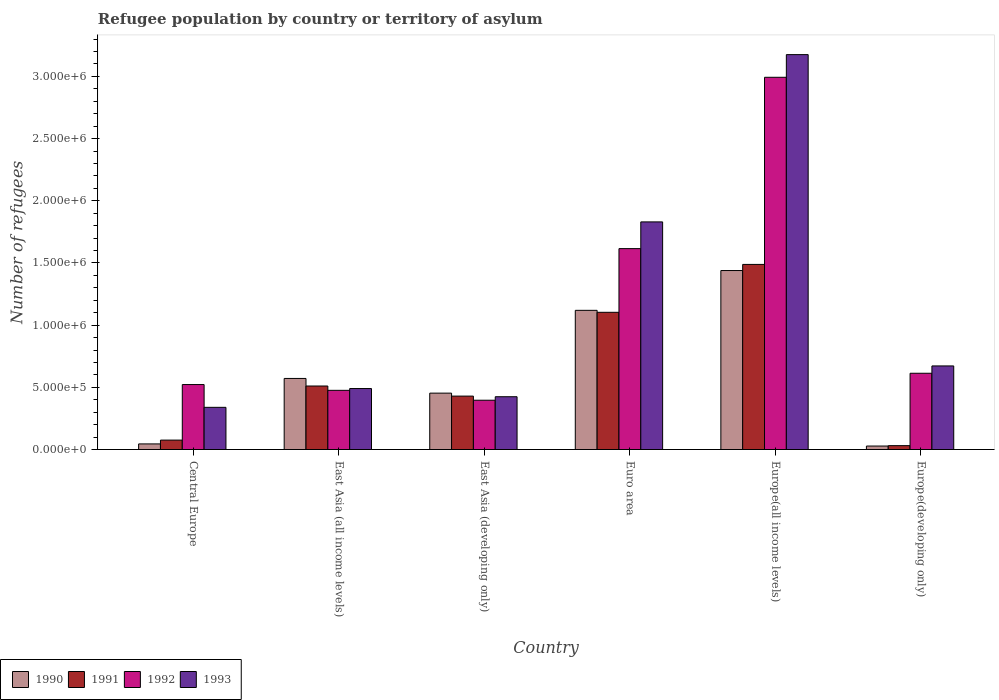Are the number of bars on each tick of the X-axis equal?
Your answer should be compact. Yes. What is the label of the 1st group of bars from the left?
Ensure brevity in your answer.  Central Europe. In how many cases, is the number of bars for a given country not equal to the number of legend labels?
Offer a very short reply. 0. What is the number of refugees in 1991 in Central Europe?
Your response must be concise. 7.57e+04. Across all countries, what is the maximum number of refugees in 1992?
Make the answer very short. 2.99e+06. Across all countries, what is the minimum number of refugees in 1992?
Provide a short and direct response. 3.96e+05. In which country was the number of refugees in 1990 maximum?
Keep it short and to the point. Europe(all income levels). In which country was the number of refugees in 1992 minimum?
Ensure brevity in your answer.  East Asia (developing only). What is the total number of refugees in 1993 in the graph?
Your response must be concise. 6.93e+06. What is the difference between the number of refugees in 1991 in Central Europe and that in East Asia (all income levels)?
Keep it short and to the point. -4.35e+05. What is the difference between the number of refugees in 1991 in Central Europe and the number of refugees in 1992 in East Asia (all income levels)?
Provide a succinct answer. -4.00e+05. What is the average number of refugees in 1992 per country?
Your answer should be compact. 1.10e+06. What is the difference between the number of refugees of/in 1992 and number of refugees of/in 1991 in Euro area?
Your response must be concise. 5.12e+05. What is the ratio of the number of refugees in 1992 in Central Europe to that in Euro area?
Provide a succinct answer. 0.32. What is the difference between the highest and the second highest number of refugees in 1990?
Keep it short and to the point. 5.48e+05. What is the difference between the highest and the lowest number of refugees in 1990?
Your answer should be compact. 1.41e+06. Is the sum of the number of refugees in 1993 in East Asia (developing only) and Euro area greater than the maximum number of refugees in 1991 across all countries?
Provide a short and direct response. Yes. Is it the case that in every country, the sum of the number of refugees in 1992 and number of refugees in 1993 is greater than the sum of number of refugees in 1990 and number of refugees in 1991?
Give a very brief answer. No. What does the 1st bar from the left in Europe(developing only) represents?
Give a very brief answer. 1990. How many bars are there?
Make the answer very short. 24. What is the difference between two consecutive major ticks on the Y-axis?
Make the answer very short. 5.00e+05. Where does the legend appear in the graph?
Ensure brevity in your answer.  Bottom left. How are the legend labels stacked?
Your response must be concise. Horizontal. What is the title of the graph?
Your answer should be compact. Refugee population by country or territory of asylum. What is the label or title of the X-axis?
Your answer should be compact. Country. What is the label or title of the Y-axis?
Make the answer very short. Number of refugees. What is the Number of refugees in 1990 in Central Europe?
Give a very brief answer. 4.51e+04. What is the Number of refugees of 1991 in Central Europe?
Your response must be concise. 7.57e+04. What is the Number of refugees of 1992 in Central Europe?
Provide a succinct answer. 5.22e+05. What is the Number of refugees of 1993 in Central Europe?
Offer a terse response. 3.39e+05. What is the Number of refugees of 1990 in East Asia (all income levels)?
Offer a terse response. 5.71e+05. What is the Number of refugees in 1991 in East Asia (all income levels)?
Your response must be concise. 5.11e+05. What is the Number of refugees of 1992 in East Asia (all income levels)?
Your response must be concise. 4.76e+05. What is the Number of refugees of 1993 in East Asia (all income levels)?
Make the answer very short. 4.90e+05. What is the Number of refugees in 1990 in East Asia (developing only)?
Keep it short and to the point. 4.53e+05. What is the Number of refugees in 1991 in East Asia (developing only)?
Keep it short and to the point. 4.30e+05. What is the Number of refugees in 1992 in East Asia (developing only)?
Provide a succinct answer. 3.96e+05. What is the Number of refugees in 1993 in East Asia (developing only)?
Give a very brief answer. 4.24e+05. What is the Number of refugees of 1990 in Euro area?
Keep it short and to the point. 1.12e+06. What is the Number of refugees of 1991 in Euro area?
Provide a short and direct response. 1.10e+06. What is the Number of refugees of 1992 in Euro area?
Keep it short and to the point. 1.62e+06. What is the Number of refugees of 1993 in Euro area?
Offer a terse response. 1.83e+06. What is the Number of refugees in 1990 in Europe(all income levels)?
Keep it short and to the point. 1.44e+06. What is the Number of refugees of 1991 in Europe(all income levels)?
Make the answer very short. 1.49e+06. What is the Number of refugees in 1992 in Europe(all income levels)?
Your answer should be compact. 2.99e+06. What is the Number of refugees in 1993 in Europe(all income levels)?
Offer a terse response. 3.18e+06. What is the Number of refugees in 1990 in Europe(developing only)?
Your answer should be very brief. 2.80e+04. What is the Number of refugees of 1991 in Europe(developing only)?
Provide a succinct answer. 3.11e+04. What is the Number of refugees in 1992 in Europe(developing only)?
Your answer should be compact. 6.13e+05. What is the Number of refugees of 1993 in Europe(developing only)?
Your answer should be compact. 6.72e+05. Across all countries, what is the maximum Number of refugees of 1990?
Keep it short and to the point. 1.44e+06. Across all countries, what is the maximum Number of refugees of 1991?
Your answer should be compact. 1.49e+06. Across all countries, what is the maximum Number of refugees of 1992?
Make the answer very short. 2.99e+06. Across all countries, what is the maximum Number of refugees of 1993?
Ensure brevity in your answer.  3.18e+06. Across all countries, what is the minimum Number of refugees of 1990?
Keep it short and to the point. 2.80e+04. Across all countries, what is the minimum Number of refugees in 1991?
Offer a terse response. 3.11e+04. Across all countries, what is the minimum Number of refugees in 1992?
Provide a short and direct response. 3.96e+05. Across all countries, what is the minimum Number of refugees in 1993?
Ensure brevity in your answer.  3.39e+05. What is the total Number of refugees of 1990 in the graph?
Your answer should be compact. 3.66e+06. What is the total Number of refugees of 1991 in the graph?
Your answer should be compact. 3.64e+06. What is the total Number of refugees in 1992 in the graph?
Ensure brevity in your answer.  6.62e+06. What is the total Number of refugees in 1993 in the graph?
Provide a short and direct response. 6.93e+06. What is the difference between the Number of refugees in 1990 in Central Europe and that in East Asia (all income levels)?
Ensure brevity in your answer.  -5.26e+05. What is the difference between the Number of refugees in 1991 in Central Europe and that in East Asia (all income levels)?
Offer a terse response. -4.35e+05. What is the difference between the Number of refugees in 1992 in Central Europe and that in East Asia (all income levels)?
Keep it short and to the point. 4.66e+04. What is the difference between the Number of refugees in 1993 in Central Europe and that in East Asia (all income levels)?
Your answer should be very brief. -1.51e+05. What is the difference between the Number of refugees in 1990 in Central Europe and that in East Asia (developing only)?
Provide a short and direct response. -4.08e+05. What is the difference between the Number of refugees of 1991 in Central Europe and that in East Asia (developing only)?
Your answer should be very brief. -3.54e+05. What is the difference between the Number of refugees in 1992 in Central Europe and that in East Asia (developing only)?
Offer a terse response. 1.26e+05. What is the difference between the Number of refugees of 1993 in Central Europe and that in East Asia (developing only)?
Provide a short and direct response. -8.53e+04. What is the difference between the Number of refugees of 1990 in Central Europe and that in Euro area?
Your answer should be compact. -1.07e+06. What is the difference between the Number of refugees in 1991 in Central Europe and that in Euro area?
Your answer should be compact. -1.03e+06. What is the difference between the Number of refugees of 1992 in Central Europe and that in Euro area?
Your answer should be compact. -1.09e+06. What is the difference between the Number of refugees in 1993 in Central Europe and that in Euro area?
Your answer should be very brief. -1.49e+06. What is the difference between the Number of refugees in 1990 in Central Europe and that in Europe(all income levels)?
Your response must be concise. -1.39e+06. What is the difference between the Number of refugees of 1991 in Central Europe and that in Europe(all income levels)?
Your response must be concise. -1.41e+06. What is the difference between the Number of refugees in 1992 in Central Europe and that in Europe(all income levels)?
Ensure brevity in your answer.  -2.47e+06. What is the difference between the Number of refugees of 1993 in Central Europe and that in Europe(all income levels)?
Your answer should be very brief. -2.84e+06. What is the difference between the Number of refugees of 1990 in Central Europe and that in Europe(developing only)?
Provide a succinct answer. 1.71e+04. What is the difference between the Number of refugees in 1991 in Central Europe and that in Europe(developing only)?
Offer a very short reply. 4.46e+04. What is the difference between the Number of refugees in 1992 in Central Europe and that in Europe(developing only)?
Offer a terse response. -9.08e+04. What is the difference between the Number of refugees in 1993 in Central Europe and that in Europe(developing only)?
Your answer should be compact. -3.33e+05. What is the difference between the Number of refugees in 1990 in East Asia (all income levels) and that in East Asia (developing only)?
Keep it short and to the point. 1.18e+05. What is the difference between the Number of refugees of 1991 in East Asia (all income levels) and that in East Asia (developing only)?
Make the answer very short. 8.11e+04. What is the difference between the Number of refugees in 1992 in East Asia (all income levels) and that in East Asia (developing only)?
Make the answer very short. 7.95e+04. What is the difference between the Number of refugees in 1993 in East Asia (all income levels) and that in East Asia (developing only)?
Give a very brief answer. 6.58e+04. What is the difference between the Number of refugees in 1990 in East Asia (all income levels) and that in Euro area?
Make the answer very short. -5.48e+05. What is the difference between the Number of refugees in 1991 in East Asia (all income levels) and that in Euro area?
Offer a terse response. -5.93e+05. What is the difference between the Number of refugees in 1992 in East Asia (all income levels) and that in Euro area?
Give a very brief answer. -1.14e+06. What is the difference between the Number of refugees in 1993 in East Asia (all income levels) and that in Euro area?
Make the answer very short. -1.34e+06. What is the difference between the Number of refugees in 1990 in East Asia (all income levels) and that in Europe(all income levels)?
Your answer should be very brief. -8.68e+05. What is the difference between the Number of refugees in 1991 in East Asia (all income levels) and that in Europe(all income levels)?
Provide a succinct answer. -9.78e+05. What is the difference between the Number of refugees of 1992 in East Asia (all income levels) and that in Europe(all income levels)?
Provide a succinct answer. -2.52e+06. What is the difference between the Number of refugees in 1993 in East Asia (all income levels) and that in Europe(all income levels)?
Your answer should be very brief. -2.68e+06. What is the difference between the Number of refugees in 1990 in East Asia (all income levels) and that in Europe(developing only)?
Offer a terse response. 5.43e+05. What is the difference between the Number of refugees in 1991 in East Asia (all income levels) and that in Europe(developing only)?
Ensure brevity in your answer.  4.80e+05. What is the difference between the Number of refugees of 1992 in East Asia (all income levels) and that in Europe(developing only)?
Give a very brief answer. -1.37e+05. What is the difference between the Number of refugees of 1993 in East Asia (all income levels) and that in Europe(developing only)?
Offer a very short reply. -1.82e+05. What is the difference between the Number of refugees of 1990 in East Asia (developing only) and that in Euro area?
Your response must be concise. -6.66e+05. What is the difference between the Number of refugees in 1991 in East Asia (developing only) and that in Euro area?
Make the answer very short. -6.74e+05. What is the difference between the Number of refugees of 1992 in East Asia (developing only) and that in Euro area?
Offer a terse response. -1.22e+06. What is the difference between the Number of refugees in 1993 in East Asia (developing only) and that in Euro area?
Offer a terse response. -1.41e+06. What is the difference between the Number of refugees in 1990 in East Asia (developing only) and that in Europe(all income levels)?
Offer a terse response. -9.86e+05. What is the difference between the Number of refugees in 1991 in East Asia (developing only) and that in Europe(all income levels)?
Provide a short and direct response. -1.06e+06. What is the difference between the Number of refugees of 1992 in East Asia (developing only) and that in Europe(all income levels)?
Ensure brevity in your answer.  -2.60e+06. What is the difference between the Number of refugees in 1993 in East Asia (developing only) and that in Europe(all income levels)?
Your answer should be compact. -2.75e+06. What is the difference between the Number of refugees in 1990 in East Asia (developing only) and that in Europe(developing only)?
Give a very brief answer. 4.25e+05. What is the difference between the Number of refugees in 1991 in East Asia (developing only) and that in Europe(developing only)?
Keep it short and to the point. 3.98e+05. What is the difference between the Number of refugees of 1992 in East Asia (developing only) and that in Europe(developing only)?
Make the answer very short. -2.17e+05. What is the difference between the Number of refugees of 1993 in East Asia (developing only) and that in Europe(developing only)?
Your answer should be compact. -2.48e+05. What is the difference between the Number of refugees in 1990 in Euro area and that in Europe(all income levels)?
Your answer should be very brief. -3.20e+05. What is the difference between the Number of refugees in 1991 in Euro area and that in Europe(all income levels)?
Ensure brevity in your answer.  -3.85e+05. What is the difference between the Number of refugees of 1992 in Euro area and that in Europe(all income levels)?
Offer a very short reply. -1.38e+06. What is the difference between the Number of refugees of 1993 in Euro area and that in Europe(all income levels)?
Offer a very short reply. -1.34e+06. What is the difference between the Number of refugees in 1990 in Euro area and that in Europe(developing only)?
Offer a very short reply. 1.09e+06. What is the difference between the Number of refugees of 1991 in Euro area and that in Europe(developing only)?
Your answer should be very brief. 1.07e+06. What is the difference between the Number of refugees in 1992 in Euro area and that in Europe(developing only)?
Offer a terse response. 1.00e+06. What is the difference between the Number of refugees of 1993 in Euro area and that in Europe(developing only)?
Offer a terse response. 1.16e+06. What is the difference between the Number of refugees of 1990 in Europe(all income levels) and that in Europe(developing only)?
Ensure brevity in your answer.  1.41e+06. What is the difference between the Number of refugees in 1991 in Europe(all income levels) and that in Europe(developing only)?
Offer a terse response. 1.46e+06. What is the difference between the Number of refugees in 1992 in Europe(all income levels) and that in Europe(developing only)?
Your response must be concise. 2.38e+06. What is the difference between the Number of refugees of 1993 in Europe(all income levels) and that in Europe(developing only)?
Your answer should be compact. 2.50e+06. What is the difference between the Number of refugees in 1990 in Central Europe and the Number of refugees in 1991 in East Asia (all income levels)?
Ensure brevity in your answer.  -4.66e+05. What is the difference between the Number of refugees of 1990 in Central Europe and the Number of refugees of 1992 in East Asia (all income levels)?
Give a very brief answer. -4.31e+05. What is the difference between the Number of refugees of 1990 in Central Europe and the Number of refugees of 1993 in East Asia (all income levels)?
Give a very brief answer. -4.45e+05. What is the difference between the Number of refugees of 1991 in Central Europe and the Number of refugees of 1992 in East Asia (all income levels)?
Your response must be concise. -4.00e+05. What is the difference between the Number of refugees of 1991 in Central Europe and the Number of refugees of 1993 in East Asia (all income levels)?
Give a very brief answer. -4.15e+05. What is the difference between the Number of refugees in 1992 in Central Europe and the Number of refugees in 1993 in East Asia (all income levels)?
Your answer should be compact. 3.21e+04. What is the difference between the Number of refugees in 1990 in Central Europe and the Number of refugees in 1991 in East Asia (developing only)?
Your answer should be very brief. -3.84e+05. What is the difference between the Number of refugees in 1990 in Central Europe and the Number of refugees in 1992 in East Asia (developing only)?
Provide a short and direct response. -3.51e+05. What is the difference between the Number of refugees in 1990 in Central Europe and the Number of refugees in 1993 in East Asia (developing only)?
Your response must be concise. -3.79e+05. What is the difference between the Number of refugees in 1991 in Central Europe and the Number of refugees in 1992 in East Asia (developing only)?
Offer a terse response. -3.21e+05. What is the difference between the Number of refugees in 1991 in Central Europe and the Number of refugees in 1993 in East Asia (developing only)?
Make the answer very short. -3.49e+05. What is the difference between the Number of refugees in 1992 in Central Europe and the Number of refugees in 1993 in East Asia (developing only)?
Provide a succinct answer. 9.79e+04. What is the difference between the Number of refugees of 1990 in Central Europe and the Number of refugees of 1991 in Euro area?
Your response must be concise. -1.06e+06. What is the difference between the Number of refugees of 1990 in Central Europe and the Number of refugees of 1992 in Euro area?
Your response must be concise. -1.57e+06. What is the difference between the Number of refugees in 1990 in Central Europe and the Number of refugees in 1993 in Euro area?
Give a very brief answer. -1.78e+06. What is the difference between the Number of refugees in 1991 in Central Europe and the Number of refugees in 1992 in Euro area?
Offer a very short reply. -1.54e+06. What is the difference between the Number of refugees in 1991 in Central Europe and the Number of refugees in 1993 in Euro area?
Offer a very short reply. -1.75e+06. What is the difference between the Number of refugees in 1992 in Central Europe and the Number of refugees in 1993 in Euro area?
Your answer should be compact. -1.31e+06. What is the difference between the Number of refugees of 1990 in Central Europe and the Number of refugees of 1991 in Europe(all income levels)?
Offer a very short reply. -1.44e+06. What is the difference between the Number of refugees in 1990 in Central Europe and the Number of refugees in 1992 in Europe(all income levels)?
Ensure brevity in your answer.  -2.95e+06. What is the difference between the Number of refugees of 1990 in Central Europe and the Number of refugees of 1993 in Europe(all income levels)?
Provide a short and direct response. -3.13e+06. What is the difference between the Number of refugees in 1991 in Central Europe and the Number of refugees in 1992 in Europe(all income levels)?
Offer a very short reply. -2.92e+06. What is the difference between the Number of refugees in 1991 in Central Europe and the Number of refugees in 1993 in Europe(all income levels)?
Your answer should be compact. -3.10e+06. What is the difference between the Number of refugees in 1992 in Central Europe and the Number of refugees in 1993 in Europe(all income levels)?
Your answer should be very brief. -2.65e+06. What is the difference between the Number of refugees in 1990 in Central Europe and the Number of refugees in 1991 in Europe(developing only)?
Provide a short and direct response. 1.40e+04. What is the difference between the Number of refugees of 1990 in Central Europe and the Number of refugees of 1992 in Europe(developing only)?
Your answer should be compact. -5.68e+05. What is the difference between the Number of refugees in 1990 in Central Europe and the Number of refugees in 1993 in Europe(developing only)?
Your answer should be very brief. -6.27e+05. What is the difference between the Number of refugees in 1991 in Central Europe and the Number of refugees in 1992 in Europe(developing only)?
Your response must be concise. -5.37e+05. What is the difference between the Number of refugees in 1991 in Central Europe and the Number of refugees in 1993 in Europe(developing only)?
Ensure brevity in your answer.  -5.96e+05. What is the difference between the Number of refugees of 1992 in Central Europe and the Number of refugees of 1993 in Europe(developing only)?
Keep it short and to the point. -1.50e+05. What is the difference between the Number of refugees in 1990 in East Asia (all income levels) and the Number of refugees in 1991 in East Asia (developing only)?
Give a very brief answer. 1.42e+05. What is the difference between the Number of refugees of 1990 in East Asia (all income levels) and the Number of refugees of 1992 in East Asia (developing only)?
Your answer should be compact. 1.75e+05. What is the difference between the Number of refugees in 1990 in East Asia (all income levels) and the Number of refugees in 1993 in East Asia (developing only)?
Keep it short and to the point. 1.47e+05. What is the difference between the Number of refugees in 1991 in East Asia (all income levels) and the Number of refugees in 1992 in East Asia (developing only)?
Provide a short and direct response. 1.14e+05. What is the difference between the Number of refugees in 1991 in East Asia (all income levels) and the Number of refugees in 1993 in East Asia (developing only)?
Keep it short and to the point. 8.62e+04. What is the difference between the Number of refugees in 1992 in East Asia (all income levels) and the Number of refugees in 1993 in East Asia (developing only)?
Give a very brief answer. 5.14e+04. What is the difference between the Number of refugees in 1990 in East Asia (all income levels) and the Number of refugees in 1991 in Euro area?
Keep it short and to the point. -5.32e+05. What is the difference between the Number of refugees in 1990 in East Asia (all income levels) and the Number of refugees in 1992 in Euro area?
Your answer should be very brief. -1.04e+06. What is the difference between the Number of refugees of 1990 in East Asia (all income levels) and the Number of refugees of 1993 in Euro area?
Provide a short and direct response. -1.26e+06. What is the difference between the Number of refugees in 1991 in East Asia (all income levels) and the Number of refugees in 1992 in Euro area?
Keep it short and to the point. -1.10e+06. What is the difference between the Number of refugees of 1991 in East Asia (all income levels) and the Number of refugees of 1993 in Euro area?
Your answer should be compact. -1.32e+06. What is the difference between the Number of refugees of 1992 in East Asia (all income levels) and the Number of refugees of 1993 in Euro area?
Give a very brief answer. -1.35e+06. What is the difference between the Number of refugees of 1990 in East Asia (all income levels) and the Number of refugees of 1991 in Europe(all income levels)?
Keep it short and to the point. -9.17e+05. What is the difference between the Number of refugees of 1990 in East Asia (all income levels) and the Number of refugees of 1992 in Europe(all income levels)?
Make the answer very short. -2.42e+06. What is the difference between the Number of refugees in 1990 in East Asia (all income levels) and the Number of refugees in 1993 in Europe(all income levels)?
Give a very brief answer. -2.60e+06. What is the difference between the Number of refugees in 1991 in East Asia (all income levels) and the Number of refugees in 1992 in Europe(all income levels)?
Your answer should be compact. -2.48e+06. What is the difference between the Number of refugees of 1991 in East Asia (all income levels) and the Number of refugees of 1993 in Europe(all income levels)?
Give a very brief answer. -2.66e+06. What is the difference between the Number of refugees of 1992 in East Asia (all income levels) and the Number of refugees of 1993 in Europe(all income levels)?
Provide a short and direct response. -2.70e+06. What is the difference between the Number of refugees of 1990 in East Asia (all income levels) and the Number of refugees of 1991 in Europe(developing only)?
Make the answer very short. 5.40e+05. What is the difference between the Number of refugees in 1990 in East Asia (all income levels) and the Number of refugees in 1992 in Europe(developing only)?
Your answer should be very brief. -4.17e+04. What is the difference between the Number of refugees of 1990 in East Asia (all income levels) and the Number of refugees of 1993 in Europe(developing only)?
Provide a succinct answer. -1.01e+05. What is the difference between the Number of refugees of 1991 in East Asia (all income levels) and the Number of refugees of 1992 in Europe(developing only)?
Your answer should be compact. -1.03e+05. What is the difference between the Number of refugees in 1991 in East Asia (all income levels) and the Number of refugees in 1993 in Europe(developing only)?
Your response must be concise. -1.61e+05. What is the difference between the Number of refugees of 1992 in East Asia (all income levels) and the Number of refugees of 1993 in Europe(developing only)?
Your answer should be compact. -1.96e+05. What is the difference between the Number of refugees of 1990 in East Asia (developing only) and the Number of refugees of 1991 in Euro area?
Your answer should be compact. -6.50e+05. What is the difference between the Number of refugees in 1990 in East Asia (developing only) and the Number of refugees in 1992 in Euro area?
Make the answer very short. -1.16e+06. What is the difference between the Number of refugees in 1990 in East Asia (developing only) and the Number of refugees in 1993 in Euro area?
Provide a short and direct response. -1.38e+06. What is the difference between the Number of refugees of 1991 in East Asia (developing only) and the Number of refugees of 1992 in Euro area?
Offer a very short reply. -1.19e+06. What is the difference between the Number of refugees in 1991 in East Asia (developing only) and the Number of refugees in 1993 in Euro area?
Provide a short and direct response. -1.40e+06. What is the difference between the Number of refugees of 1992 in East Asia (developing only) and the Number of refugees of 1993 in Euro area?
Make the answer very short. -1.43e+06. What is the difference between the Number of refugees in 1990 in East Asia (developing only) and the Number of refugees in 1991 in Europe(all income levels)?
Make the answer very short. -1.03e+06. What is the difference between the Number of refugees of 1990 in East Asia (developing only) and the Number of refugees of 1992 in Europe(all income levels)?
Make the answer very short. -2.54e+06. What is the difference between the Number of refugees in 1990 in East Asia (developing only) and the Number of refugees in 1993 in Europe(all income levels)?
Ensure brevity in your answer.  -2.72e+06. What is the difference between the Number of refugees of 1991 in East Asia (developing only) and the Number of refugees of 1992 in Europe(all income levels)?
Provide a succinct answer. -2.56e+06. What is the difference between the Number of refugees of 1991 in East Asia (developing only) and the Number of refugees of 1993 in Europe(all income levels)?
Offer a very short reply. -2.75e+06. What is the difference between the Number of refugees in 1992 in East Asia (developing only) and the Number of refugees in 1993 in Europe(all income levels)?
Offer a very short reply. -2.78e+06. What is the difference between the Number of refugees of 1990 in East Asia (developing only) and the Number of refugees of 1991 in Europe(developing only)?
Your answer should be very brief. 4.22e+05. What is the difference between the Number of refugees in 1990 in East Asia (developing only) and the Number of refugees in 1992 in Europe(developing only)?
Keep it short and to the point. -1.60e+05. What is the difference between the Number of refugees of 1990 in East Asia (developing only) and the Number of refugees of 1993 in Europe(developing only)?
Your answer should be very brief. -2.19e+05. What is the difference between the Number of refugees of 1991 in East Asia (developing only) and the Number of refugees of 1992 in Europe(developing only)?
Your answer should be very brief. -1.84e+05. What is the difference between the Number of refugees of 1991 in East Asia (developing only) and the Number of refugees of 1993 in Europe(developing only)?
Provide a succinct answer. -2.43e+05. What is the difference between the Number of refugees in 1992 in East Asia (developing only) and the Number of refugees in 1993 in Europe(developing only)?
Provide a short and direct response. -2.76e+05. What is the difference between the Number of refugees of 1990 in Euro area and the Number of refugees of 1991 in Europe(all income levels)?
Offer a terse response. -3.69e+05. What is the difference between the Number of refugees in 1990 in Euro area and the Number of refugees in 1992 in Europe(all income levels)?
Offer a very short reply. -1.87e+06. What is the difference between the Number of refugees of 1990 in Euro area and the Number of refugees of 1993 in Europe(all income levels)?
Ensure brevity in your answer.  -2.06e+06. What is the difference between the Number of refugees in 1991 in Euro area and the Number of refugees in 1992 in Europe(all income levels)?
Keep it short and to the point. -1.89e+06. What is the difference between the Number of refugees of 1991 in Euro area and the Number of refugees of 1993 in Europe(all income levels)?
Provide a succinct answer. -2.07e+06. What is the difference between the Number of refugees in 1992 in Euro area and the Number of refugees in 1993 in Europe(all income levels)?
Make the answer very short. -1.56e+06. What is the difference between the Number of refugees of 1990 in Euro area and the Number of refugees of 1991 in Europe(developing only)?
Your response must be concise. 1.09e+06. What is the difference between the Number of refugees in 1990 in Euro area and the Number of refugees in 1992 in Europe(developing only)?
Ensure brevity in your answer.  5.06e+05. What is the difference between the Number of refugees of 1990 in Euro area and the Number of refugees of 1993 in Europe(developing only)?
Give a very brief answer. 4.47e+05. What is the difference between the Number of refugees in 1991 in Euro area and the Number of refugees in 1992 in Europe(developing only)?
Your answer should be very brief. 4.90e+05. What is the difference between the Number of refugees in 1991 in Euro area and the Number of refugees in 1993 in Europe(developing only)?
Your answer should be compact. 4.31e+05. What is the difference between the Number of refugees of 1992 in Euro area and the Number of refugees of 1993 in Europe(developing only)?
Make the answer very short. 9.43e+05. What is the difference between the Number of refugees in 1990 in Europe(all income levels) and the Number of refugees in 1991 in Europe(developing only)?
Your answer should be very brief. 1.41e+06. What is the difference between the Number of refugees of 1990 in Europe(all income levels) and the Number of refugees of 1992 in Europe(developing only)?
Give a very brief answer. 8.26e+05. What is the difference between the Number of refugees of 1990 in Europe(all income levels) and the Number of refugees of 1993 in Europe(developing only)?
Ensure brevity in your answer.  7.67e+05. What is the difference between the Number of refugees in 1991 in Europe(all income levels) and the Number of refugees in 1992 in Europe(developing only)?
Your answer should be very brief. 8.75e+05. What is the difference between the Number of refugees of 1991 in Europe(all income levels) and the Number of refugees of 1993 in Europe(developing only)?
Keep it short and to the point. 8.16e+05. What is the difference between the Number of refugees of 1992 in Europe(all income levels) and the Number of refugees of 1993 in Europe(developing only)?
Provide a short and direct response. 2.32e+06. What is the average Number of refugees in 1990 per country?
Provide a short and direct response. 6.09e+05. What is the average Number of refugees of 1991 per country?
Offer a terse response. 6.06e+05. What is the average Number of refugees in 1992 per country?
Your response must be concise. 1.10e+06. What is the average Number of refugees of 1993 per country?
Your answer should be very brief. 1.16e+06. What is the difference between the Number of refugees in 1990 and Number of refugees in 1991 in Central Europe?
Ensure brevity in your answer.  -3.06e+04. What is the difference between the Number of refugees in 1990 and Number of refugees in 1992 in Central Europe?
Make the answer very short. -4.77e+05. What is the difference between the Number of refugees in 1990 and Number of refugees in 1993 in Central Europe?
Your response must be concise. -2.94e+05. What is the difference between the Number of refugees in 1991 and Number of refugees in 1992 in Central Europe?
Ensure brevity in your answer.  -4.47e+05. What is the difference between the Number of refugees of 1991 and Number of refugees of 1993 in Central Europe?
Provide a succinct answer. -2.63e+05. What is the difference between the Number of refugees in 1992 and Number of refugees in 1993 in Central Europe?
Offer a terse response. 1.83e+05. What is the difference between the Number of refugees of 1990 and Number of refugees of 1991 in East Asia (all income levels)?
Offer a very short reply. 6.08e+04. What is the difference between the Number of refugees in 1990 and Number of refugees in 1992 in East Asia (all income levels)?
Your answer should be compact. 9.57e+04. What is the difference between the Number of refugees in 1990 and Number of refugees in 1993 in East Asia (all income levels)?
Keep it short and to the point. 8.12e+04. What is the difference between the Number of refugees of 1991 and Number of refugees of 1992 in East Asia (all income levels)?
Make the answer very short. 3.49e+04. What is the difference between the Number of refugees of 1991 and Number of refugees of 1993 in East Asia (all income levels)?
Your answer should be very brief. 2.04e+04. What is the difference between the Number of refugees in 1992 and Number of refugees in 1993 in East Asia (all income levels)?
Ensure brevity in your answer.  -1.44e+04. What is the difference between the Number of refugees of 1990 and Number of refugees of 1991 in East Asia (developing only)?
Make the answer very short. 2.38e+04. What is the difference between the Number of refugees of 1990 and Number of refugees of 1992 in East Asia (developing only)?
Offer a very short reply. 5.70e+04. What is the difference between the Number of refugees of 1990 and Number of refugees of 1993 in East Asia (developing only)?
Offer a terse response. 2.89e+04. What is the difference between the Number of refugees of 1991 and Number of refugees of 1992 in East Asia (developing only)?
Your answer should be compact. 3.32e+04. What is the difference between the Number of refugees of 1991 and Number of refugees of 1993 in East Asia (developing only)?
Your answer should be compact. 5099. What is the difference between the Number of refugees in 1992 and Number of refugees in 1993 in East Asia (developing only)?
Keep it short and to the point. -2.81e+04. What is the difference between the Number of refugees of 1990 and Number of refugees of 1991 in Euro area?
Offer a terse response. 1.58e+04. What is the difference between the Number of refugees of 1990 and Number of refugees of 1992 in Euro area?
Make the answer very short. -4.96e+05. What is the difference between the Number of refugees in 1990 and Number of refugees in 1993 in Euro area?
Your answer should be compact. -7.11e+05. What is the difference between the Number of refugees in 1991 and Number of refugees in 1992 in Euro area?
Your answer should be compact. -5.12e+05. What is the difference between the Number of refugees in 1991 and Number of refugees in 1993 in Euro area?
Offer a very short reply. -7.27e+05. What is the difference between the Number of refugees of 1992 and Number of refugees of 1993 in Euro area?
Provide a succinct answer. -2.15e+05. What is the difference between the Number of refugees of 1990 and Number of refugees of 1991 in Europe(all income levels)?
Provide a short and direct response. -4.92e+04. What is the difference between the Number of refugees of 1990 and Number of refugees of 1992 in Europe(all income levels)?
Offer a terse response. -1.55e+06. What is the difference between the Number of refugees in 1990 and Number of refugees in 1993 in Europe(all income levels)?
Give a very brief answer. -1.74e+06. What is the difference between the Number of refugees of 1991 and Number of refugees of 1992 in Europe(all income levels)?
Give a very brief answer. -1.50e+06. What is the difference between the Number of refugees of 1991 and Number of refugees of 1993 in Europe(all income levels)?
Provide a succinct answer. -1.69e+06. What is the difference between the Number of refugees in 1992 and Number of refugees in 1993 in Europe(all income levels)?
Ensure brevity in your answer.  -1.82e+05. What is the difference between the Number of refugees of 1990 and Number of refugees of 1991 in Europe(developing only)?
Your response must be concise. -3113. What is the difference between the Number of refugees of 1990 and Number of refugees of 1992 in Europe(developing only)?
Your response must be concise. -5.85e+05. What is the difference between the Number of refugees in 1990 and Number of refugees in 1993 in Europe(developing only)?
Make the answer very short. -6.44e+05. What is the difference between the Number of refugees in 1991 and Number of refugees in 1992 in Europe(developing only)?
Your response must be concise. -5.82e+05. What is the difference between the Number of refugees in 1991 and Number of refugees in 1993 in Europe(developing only)?
Your answer should be very brief. -6.41e+05. What is the difference between the Number of refugees of 1992 and Number of refugees of 1993 in Europe(developing only)?
Keep it short and to the point. -5.89e+04. What is the ratio of the Number of refugees of 1990 in Central Europe to that in East Asia (all income levels)?
Your answer should be very brief. 0.08. What is the ratio of the Number of refugees in 1991 in Central Europe to that in East Asia (all income levels)?
Provide a short and direct response. 0.15. What is the ratio of the Number of refugees in 1992 in Central Europe to that in East Asia (all income levels)?
Your answer should be very brief. 1.1. What is the ratio of the Number of refugees in 1993 in Central Europe to that in East Asia (all income levels)?
Provide a short and direct response. 0.69. What is the ratio of the Number of refugees in 1990 in Central Europe to that in East Asia (developing only)?
Keep it short and to the point. 0.1. What is the ratio of the Number of refugees of 1991 in Central Europe to that in East Asia (developing only)?
Your answer should be compact. 0.18. What is the ratio of the Number of refugees in 1992 in Central Europe to that in East Asia (developing only)?
Offer a terse response. 1.32. What is the ratio of the Number of refugees in 1993 in Central Europe to that in East Asia (developing only)?
Your answer should be very brief. 0.8. What is the ratio of the Number of refugees in 1990 in Central Europe to that in Euro area?
Offer a very short reply. 0.04. What is the ratio of the Number of refugees of 1991 in Central Europe to that in Euro area?
Offer a terse response. 0.07. What is the ratio of the Number of refugees in 1992 in Central Europe to that in Euro area?
Ensure brevity in your answer.  0.32. What is the ratio of the Number of refugees of 1993 in Central Europe to that in Euro area?
Your response must be concise. 0.19. What is the ratio of the Number of refugees of 1990 in Central Europe to that in Europe(all income levels)?
Provide a succinct answer. 0.03. What is the ratio of the Number of refugees in 1991 in Central Europe to that in Europe(all income levels)?
Offer a very short reply. 0.05. What is the ratio of the Number of refugees of 1992 in Central Europe to that in Europe(all income levels)?
Give a very brief answer. 0.17. What is the ratio of the Number of refugees of 1993 in Central Europe to that in Europe(all income levels)?
Offer a terse response. 0.11. What is the ratio of the Number of refugees of 1990 in Central Europe to that in Europe(developing only)?
Provide a short and direct response. 1.61. What is the ratio of the Number of refugees in 1991 in Central Europe to that in Europe(developing only)?
Provide a succinct answer. 2.43. What is the ratio of the Number of refugees in 1992 in Central Europe to that in Europe(developing only)?
Your answer should be compact. 0.85. What is the ratio of the Number of refugees in 1993 in Central Europe to that in Europe(developing only)?
Your response must be concise. 0.5. What is the ratio of the Number of refugees in 1990 in East Asia (all income levels) to that in East Asia (developing only)?
Your answer should be compact. 1.26. What is the ratio of the Number of refugees of 1991 in East Asia (all income levels) to that in East Asia (developing only)?
Make the answer very short. 1.19. What is the ratio of the Number of refugees of 1992 in East Asia (all income levels) to that in East Asia (developing only)?
Keep it short and to the point. 1.2. What is the ratio of the Number of refugees of 1993 in East Asia (all income levels) to that in East Asia (developing only)?
Offer a very short reply. 1.16. What is the ratio of the Number of refugees in 1990 in East Asia (all income levels) to that in Euro area?
Your response must be concise. 0.51. What is the ratio of the Number of refugees of 1991 in East Asia (all income levels) to that in Euro area?
Your response must be concise. 0.46. What is the ratio of the Number of refugees of 1992 in East Asia (all income levels) to that in Euro area?
Provide a short and direct response. 0.29. What is the ratio of the Number of refugees of 1993 in East Asia (all income levels) to that in Euro area?
Your answer should be very brief. 0.27. What is the ratio of the Number of refugees in 1990 in East Asia (all income levels) to that in Europe(all income levels)?
Ensure brevity in your answer.  0.4. What is the ratio of the Number of refugees of 1991 in East Asia (all income levels) to that in Europe(all income levels)?
Offer a terse response. 0.34. What is the ratio of the Number of refugees of 1992 in East Asia (all income levels) to that in Europe(all income levels)?
Offer a very short reply. 0.16. What is the ratio of the Number of refugees of 1993 in East Asia (all income levels) to that in Europe(all income levels)?
Give a very brief answer. 0.15. What is the ratio of the Number of refugees of 1990 in East Asia (all income levels) to that in Europe(developing only)?
Provide a succinct answer. 20.41. What is the ratio of the Number of refugees of 1991 in East Asia (all income levels) to that in Europe(developing only)?
Make the answer very short. 16.41. What is the ratio of the Number of refugees in 1992 in East Asia (all income levels) to that in Europe(developing only)?
Provide a succinct answer. 0.78. What is the ratio of the Number of refugees of 1993 in East Asia (all income levels) to that in Europe(developing only)?
Your response must be concise. 0.73. What is the ratio of the Number of refugees in 1990 in East Asia (developing only) to that in Euro area?
Offer a terse response. 0.41. What is the ratio of the Number of refugees of 1991 in East Asia (developing only) to that in Euro area?
Offer a terse response. 0.39. What is the ratio of the Number of refugees in 1992 in East Asia (developing only) to that in Euro area?
Give a very brief answer. 0.25. What is the ratio of the Number of refugees of 1993 in East Asia (developing only) to that in Euro area?
Make the answer very short. 0.23. What is the ratio of the Number of refugees in 1990 in East Asia (developing only) to that in Europe(all income levels)?
Keep it short and to the point. 0.32. What is the ratio of the Number of refugees of 1991 in East Asia (developing only) to that in Europe(all income levels)?
Give a very brief answer. 0.29. What is the ratio of the Number of refugees in 1992 in East Asia (developing only) to that in Europe(all income levels)?
Your response must be concise. 0.13. What is the ratio of the Number of refugees in 1993 in East Asia (developing only) to that in Europe(all income levels)?
Your response must be concise. 0.13. What is the ratio of the Number of refugees in 1990 in East Asia (developing only) to that in Europe(developing only)?
Give a very brief answer. 16.19. What is the ratio of the Number of refugees of 1991 in East Asia (developing only) to that in Europe(developing only)?
Keep it short and to the point. 13.81. What is the ratio of the Number of refugees in 1992 in East Asia (developing only) to that in Europe(developing only)?
Your answer should be very brief. 0.65. What is the ratio of the Number of refugees of 1993 in East Asia (developing only) to that in Europe(developing only)?
Your answer should be very brief. 0.63. What is the ratio of the Number of refugees of 1990 in Euro area to that in Europe(all income levels)?
Give a very brief answer. 0.78. What is the ratio of the Number of refugees of 1991 in Euro area to that in Europe(all income levels)?
Keep it short and to the point. 0.74. What is the ratio of the Number of refugees in 1992 in Euro area to that in Europe(all income levels)?
Ensure brevity in your answer.  0.54. What is the ratio of the Number of refugees in 1993 in Euro area to that in Europe(all income levels)?
Ensure brevity in your answer.  0.58. What is the ratio of the Number of refugees of 1990 in Euro area to that in Europe(developing only)?
Keep it short and to the point. 39.97. What is the ratio of the Number of refugees of 1991 in Euro area to that in Europe(developing only)?
Your answer should be very brief. 35.46. What is the ratio of the Number of refugees of 1992 in Euro area to that in Europe(developing only)?
Offer a very short reply. 2.63. What is the ratio of the Number of refugees of 1993 in Euro area to that in Europe(developing only)?
Your response must be concise. 2.72. What is the ratio of the Number of refugees of 1990 in Europe(all income levels) to that in Europe(developing only)?
Give a very brief answer. 51.39. What is the ratio of the Number of refugees in 1991 in Europe(all income levels) to that in Europe(developing only)?
Your response must be concise. 47.83. What is the ratio of the Number of refugees of 1992 in Europe(all income levels) to that in Europe(developing only)?
Ensure brevity in your answer.  4.88. What is the ratio of the Number of refugees of 1993 in Europe(all income levels) to that in Europe(developing only)?
Give a very brief answer. 4.72. What is the difference between the highest and the second highest Number of refugees in 1990?
Give a very brief answer. 3.20e+05. What is the difference between the highest and the second highest Number of refugees of 1991?
Your answer should be very brief. 3.85e+05. What is the difference between the highest and the second highest Number of refugees of 1992?
Your answer should be compact. 1.38e+06. What is the difference between the highest and the second highest Number of refugees of 1993?
Your answer should be very brief. 1.34e+06. What is the difference between the highest and the lowest Number of refugees in 1990?
Provide a succinct answer. 1.41e+06. What is the difference between the highest and the lowest Number of refugees of 1991?
Offer a terse response. 1.46e+06. What is the difference between the highest and the lowest Number of refugees of 1992?
Provide a short and direct response. 2.60e+06. What is the difference between the highest and the lowest Number of refugees of 1993?
Your answer should be compact. 2.84e+06. 